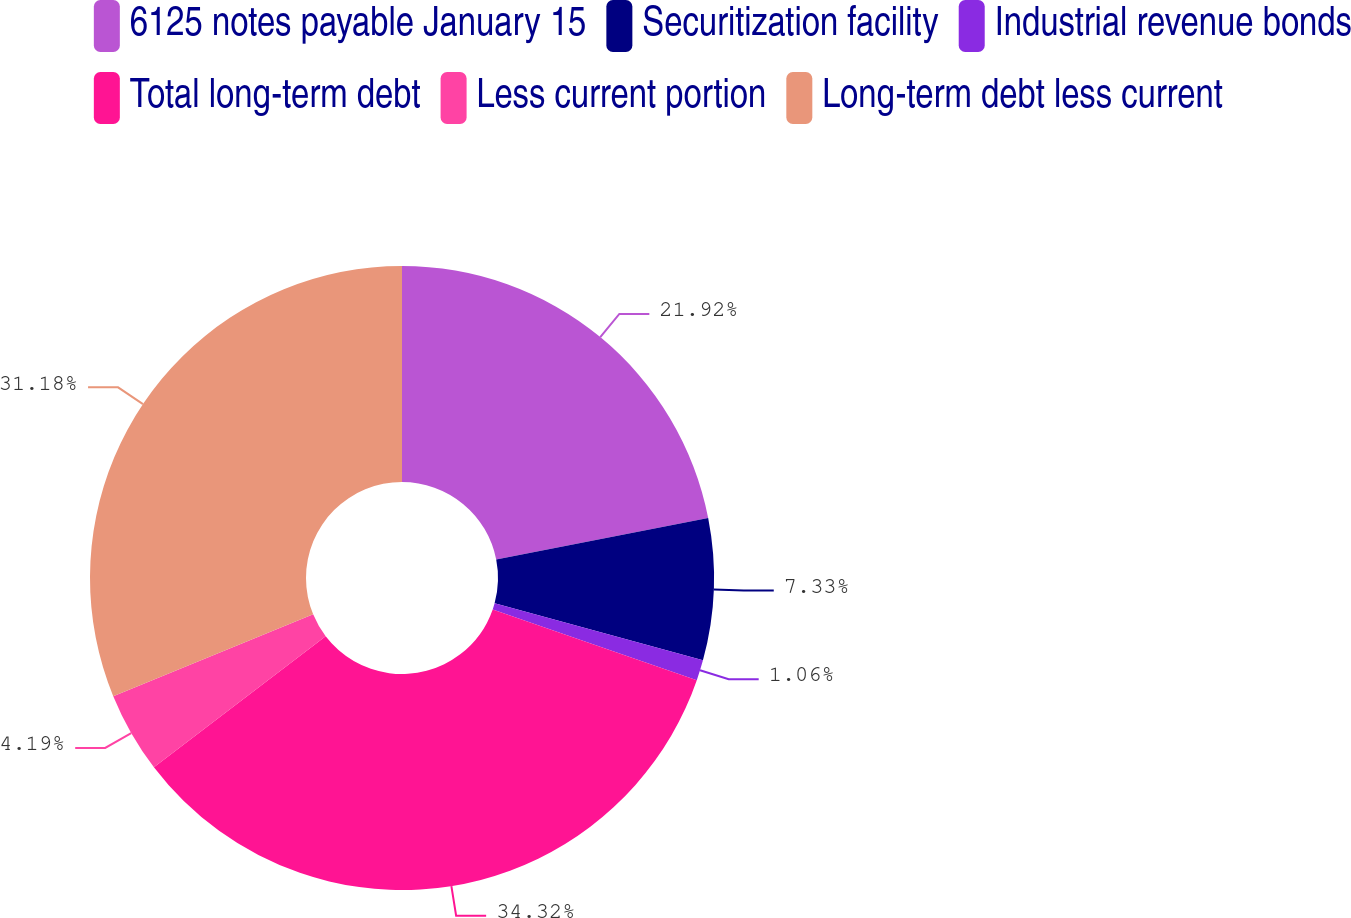Convert chart to OTSL. <chart><loc_0><loc_0><loc_500><loc_500><pie_chart><fcel>6125 notes payable January 15<fcel>Securitization facility<fcel>Industrial revenue bonds<fcel>Total long-term debt<fcel>Less current portion<fcel>Long-term debt less current<nl><fcel>21.92%<fcel>7.33%<fcel>1.06%<fcel>34.32%<fcel>4.19%<fcel>31.18%<nl></chart> 